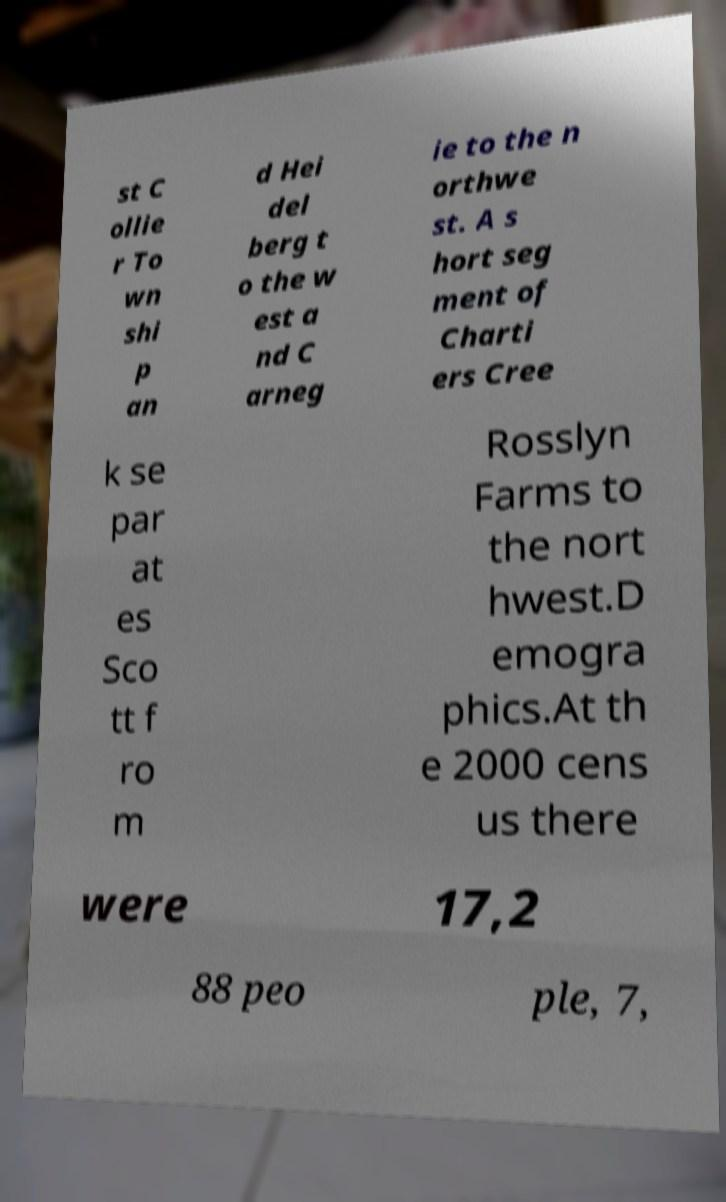Could you assist in decoding the text presented in this image and type it out clearly? st C ollie r To wn shi p an d Hei del berg t o the w est a nd C arneg ie to the n orthwe st. A s hort seg ment of Charti ers Cree k se par at es Sco tt f ro m Rosslyn Farms to the nort hwest.D emogra phics.At th e 2000 cens us there were 17,2 88 peo ple, 7, 